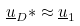<formula> <loc_0><loc_0><loc_500><loc_500>\underline { u } _ { D } * \approx \underline { u } _ { 1 }</formula> 